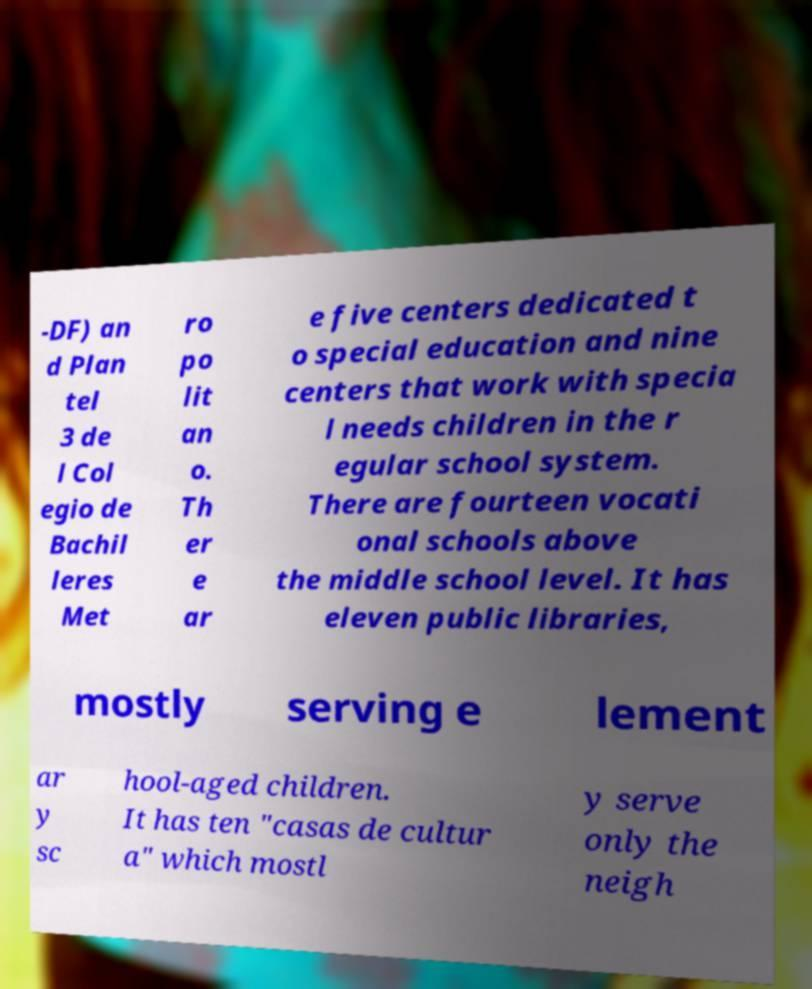Please read and relay the text visible in this image. What does it say? -DF) an d Plan tel 3 de l Col egio de Bachil leres Met ro po lit an o. Th er e ar e five centers dedicated t o special education and nine centers that work with specia l needs children in the r egular school system. There are fourteen vocati onal schools above the middle school level. It has eleven public libraries, mostly serving e lement ar y sc hool-aged children. It has ten "casas de cultur a" which mostl y serve only the neigh 